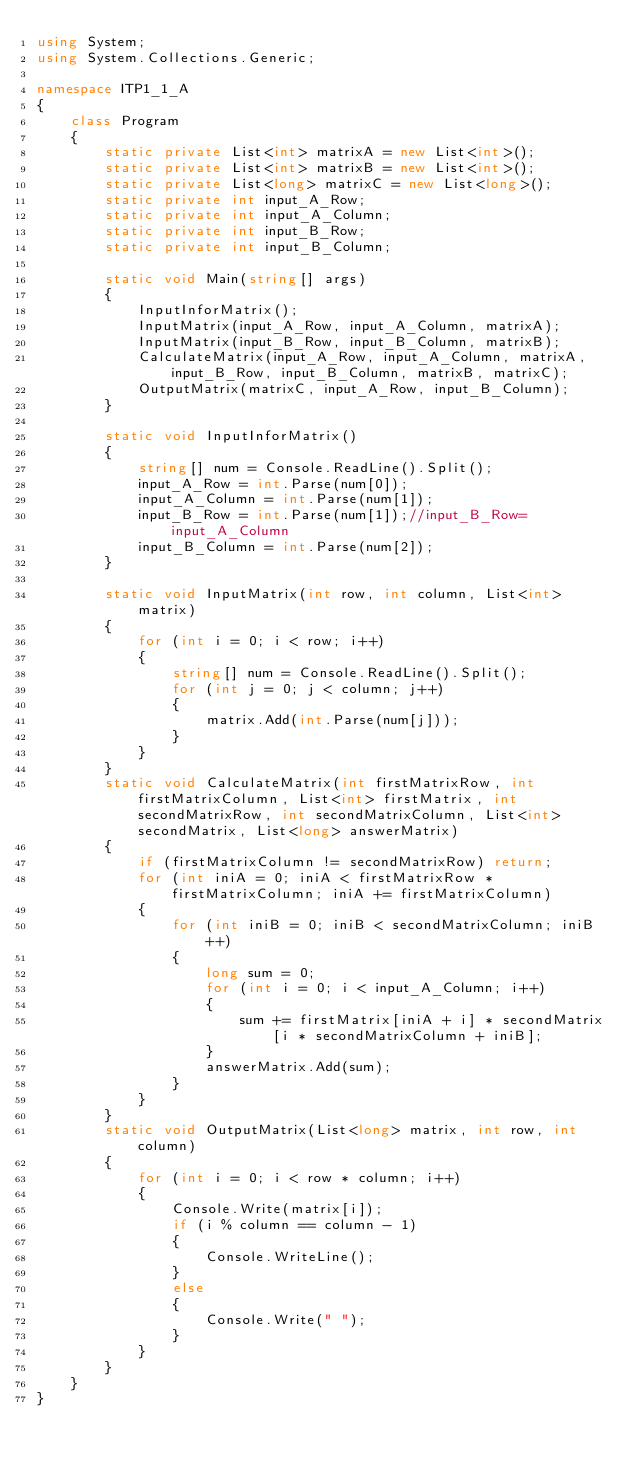<code> <loc_0><loc_0><loc_500><loc_500><_C#_>using System;
using System.Collections.Generic;

namespace ITP1_1_A
{
    class Program
    {
        static private List<int> matrixA = new List<int>();
        static private List<int> matrixB = new List<int>();
        static private List<long> matrixC = new List<long>();
        static private int input_A_Row;
        static private int input_A_Column;
        static private int input_B_Row;
        static private int input_B_Column;

        static void Main(string[] args)
        {
            InputInforMatrix();
            InputMatrix(input_A_Row, input_A_Column, matrixA);
            InputMatrix(input_B_Row, input_B_Column, matrixB);
            CalculateMatrix(input_A_Row, input_A_Column, matrixA, input_B_Row, input_B_Column, matrixB, matrixC);
            OutputMatrix(matrixC, input_A_Row, input_B_Column);
        }

        static void InputInforMatrix()
        {
            string[] num = Console.ReadLine().Split();
            input_A_Row = int.Parse(num[0]);
            input_A_Column = int.Parse(num[1]);
            input_B_Row = int.Parse(num[1]);//input_B_Row=input_A_Column
            input_B_Column = int.Parse(num[2]);
        }

        static void InputMatrix(int row, int column, List<int> matrix)
        {
            for (int i = 0; i < row; i++)
            {
                string[] num = Console.ReadLine().Split();
                for (int j = 0; j < column; j++)
                {
                    matrix.Add(int.Parse(num[j]));
                }
            }
        }
        static void CalculateMatrix(int firstMatrixRow, int firstMatrixColumn, List<int> firstMatrix, int secondMatrixRow, int secondMatrixColumn, List<int> secondMatrix, List<long> answerMatrix)
        {
            if (firstMatrixColumn != secondMatrixRow) return;
            for (int iniA = 0; iniA < firstMatrixRow * firstMatrixColumn; iniA += firstMatrixColumn)
            {
                for (int iniB = 0; iniB < secondMatrixColumn; iniB++)
                {
                    long sum = 0;
                    for (int i = 0; i < input_A_Column; i++)
                    {
                        sum += firstMatrix[iniA + i] * secondMatrix[i * secondMatrixColumn + iniB];
                    }
                    answerMatrix.Add(sum);
                }
            }
        }
        static void OutputMatrix(List<long> matrix, int row, int column)
        {
            for (int i = 0; i < row * column; i++)
            {
                Console.Write(matrix[i]);
                if (i % column == column - 1)
                {
                    Console.WriteLine();
                }
                else
                {
                    Console.Write(" ");
                }
            }
        }
    }
}

</code> 